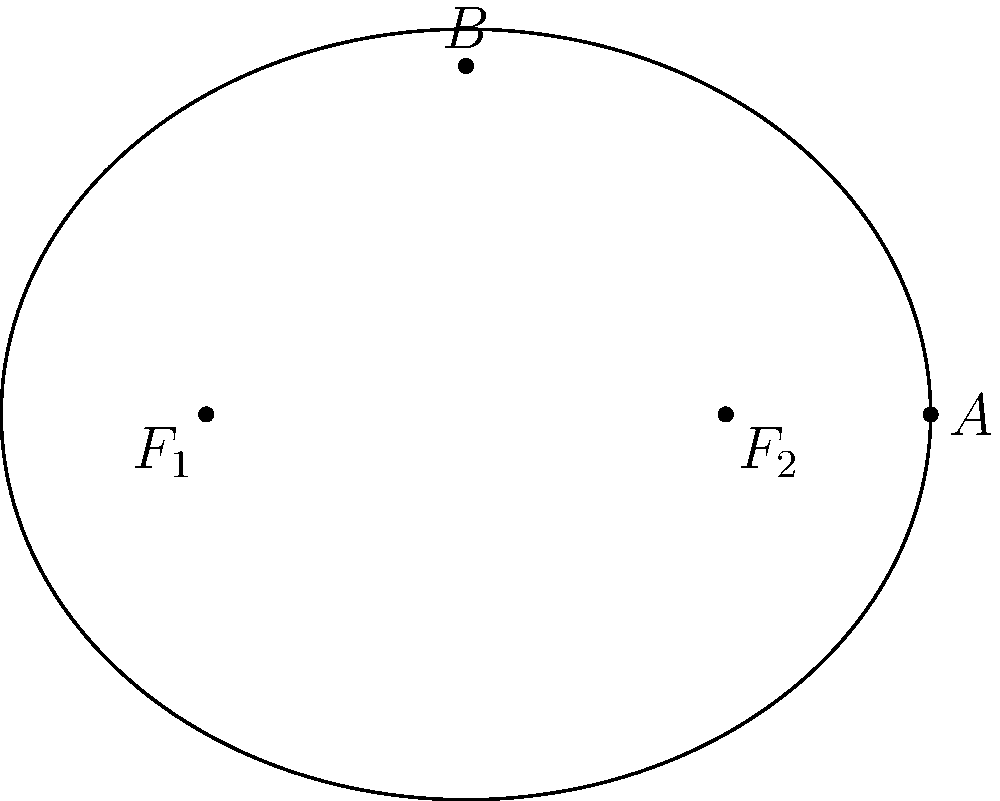Given the equation of an ellipse $\frac{x^2}{16} + \frac{y^2}{9} = 1$, find the coordinates of its focal points. To find the focal points of the ellipse, we'll follow these steps:

1) The general form of an ellipse equation is $\frac{x^2}{a^2} + \frac{y^2}{b^2} = 1$, where $a$ is the length of the semi-major axis and $b$ is the length of the semi-minor axis.

2) From our equation $\frac{x^2}{16} + \frac{y^2}{9} = 1$, we can identify:
   $a^2 = 16$, so $a = 4$
   $b^2 = 9$, so $b = 3$

3) The focal points of an ellipse lie on its major axis. Since $a > b$, the major axis is horizontal (along the x-axis).

4) The distance from the center to a focal point, let's call it $c$, is given by the equation: $c^2 = a^2 - b^2$

5) Substituting our values:
   $c^2 = 4^2 - 3^2 = 16 - 9 = 7$
   $c = \sqrt{7}$

6) The focal points are located at $(\pm c, 0)$ on the x-axis.

Therefore, the focal points are $(-\sqrt{7}, 0)$ and $(\sqrt{7}, 0)$.
Answer: $(-\sqrt{7}, 0)$ and $(\sqrt{7}, 0)$ 